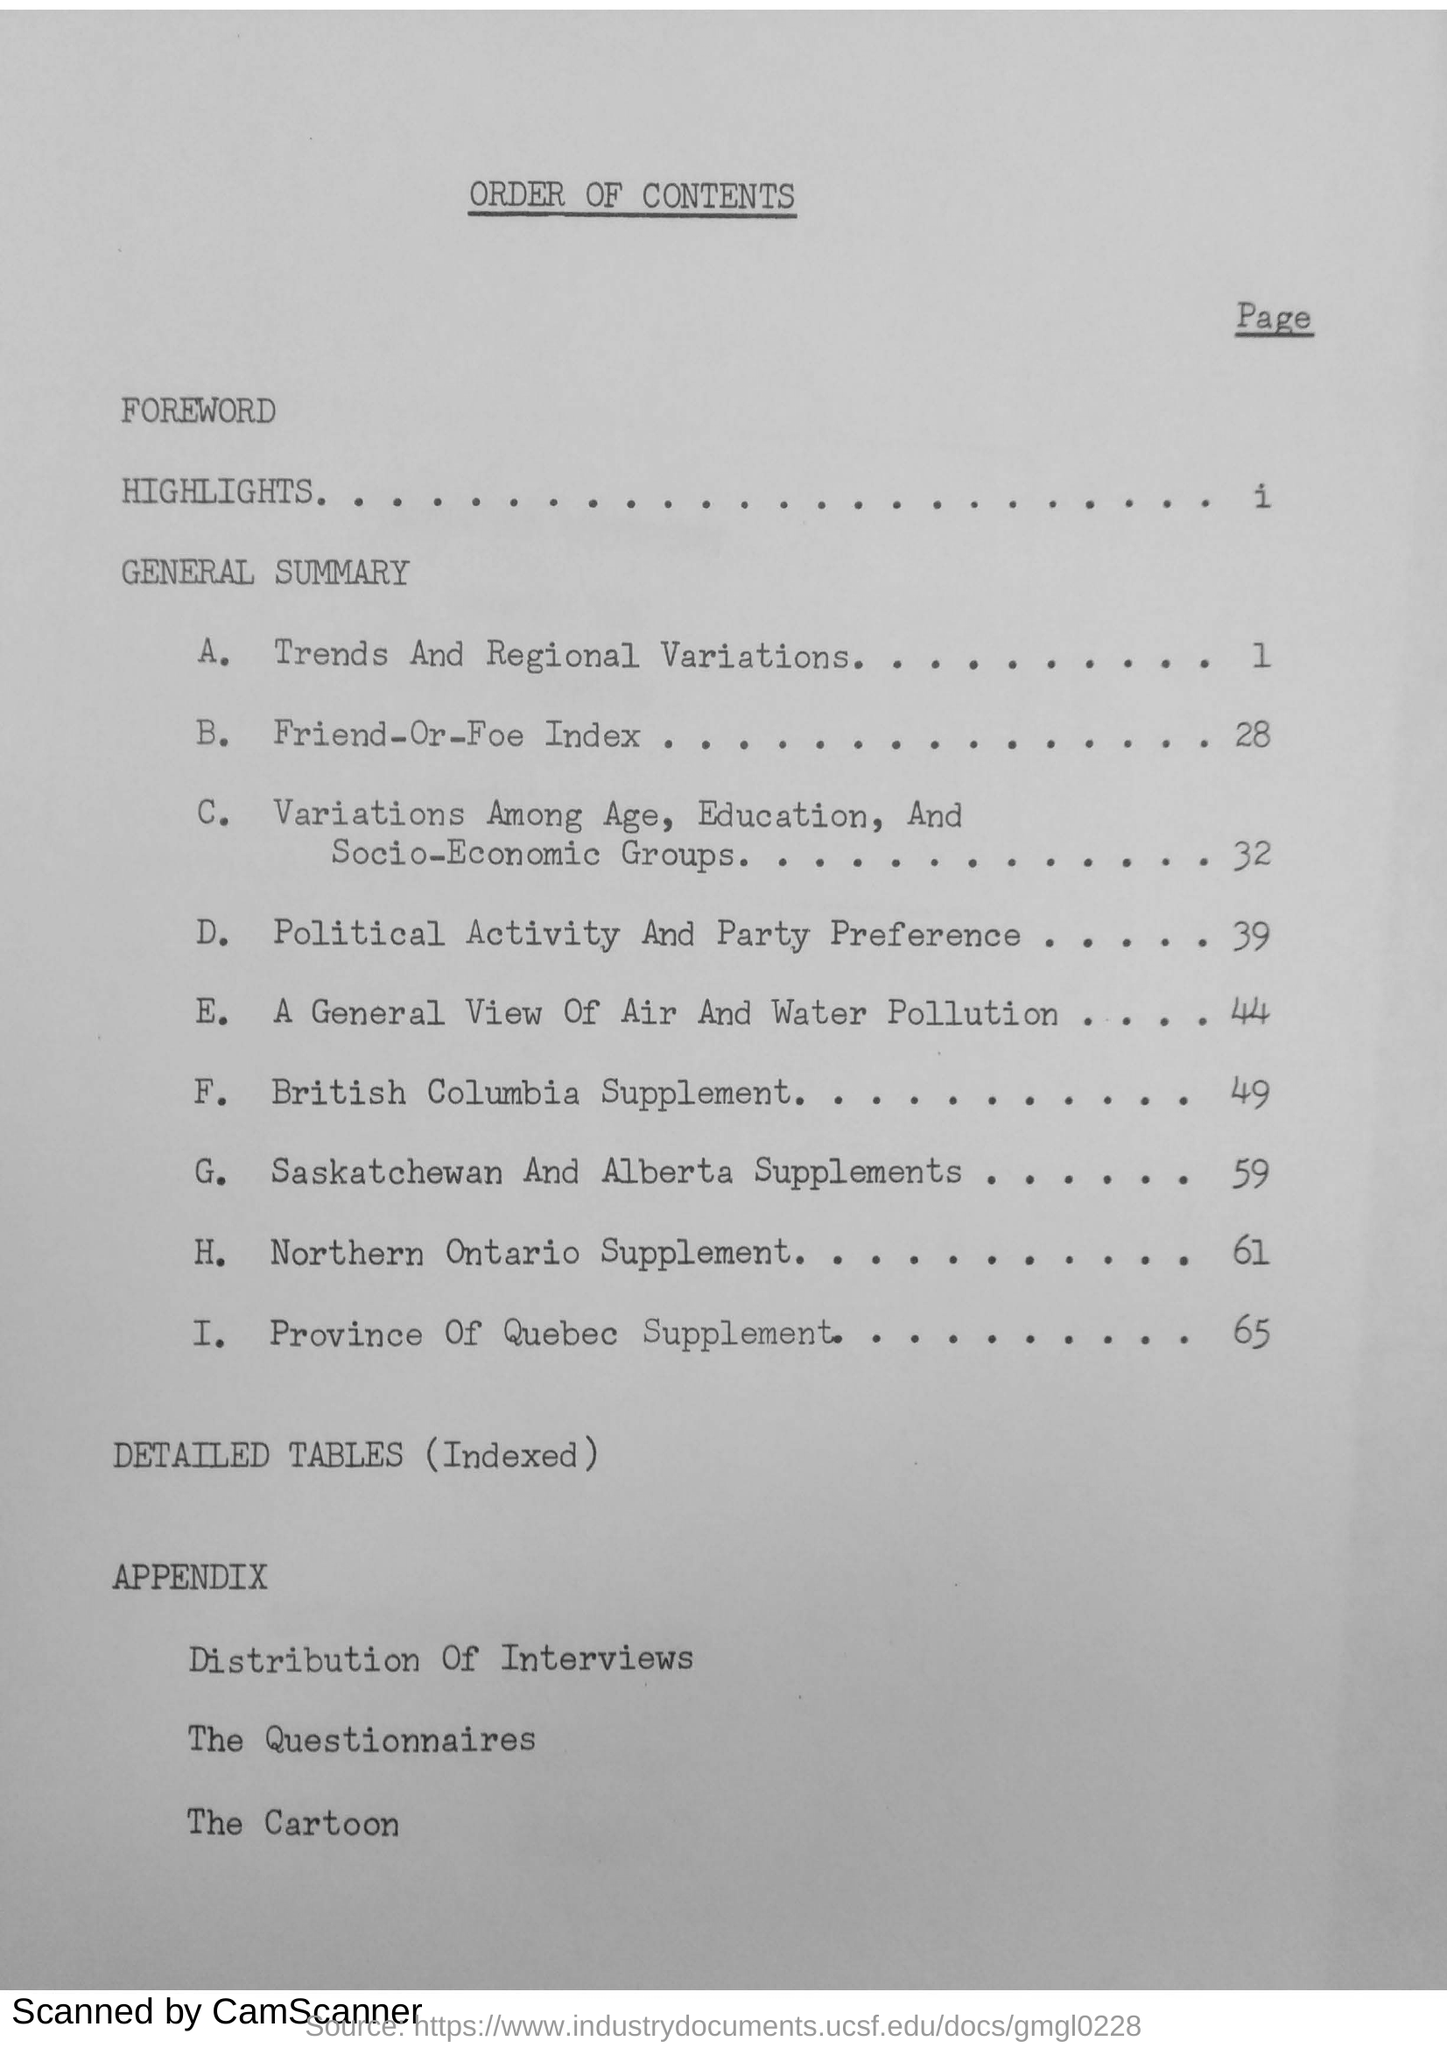What is the page number of British Columbia Supplement?
Offer a terse response. 49. What is the document about?
Your response must be concise. ORDER OF CONTENTS. 